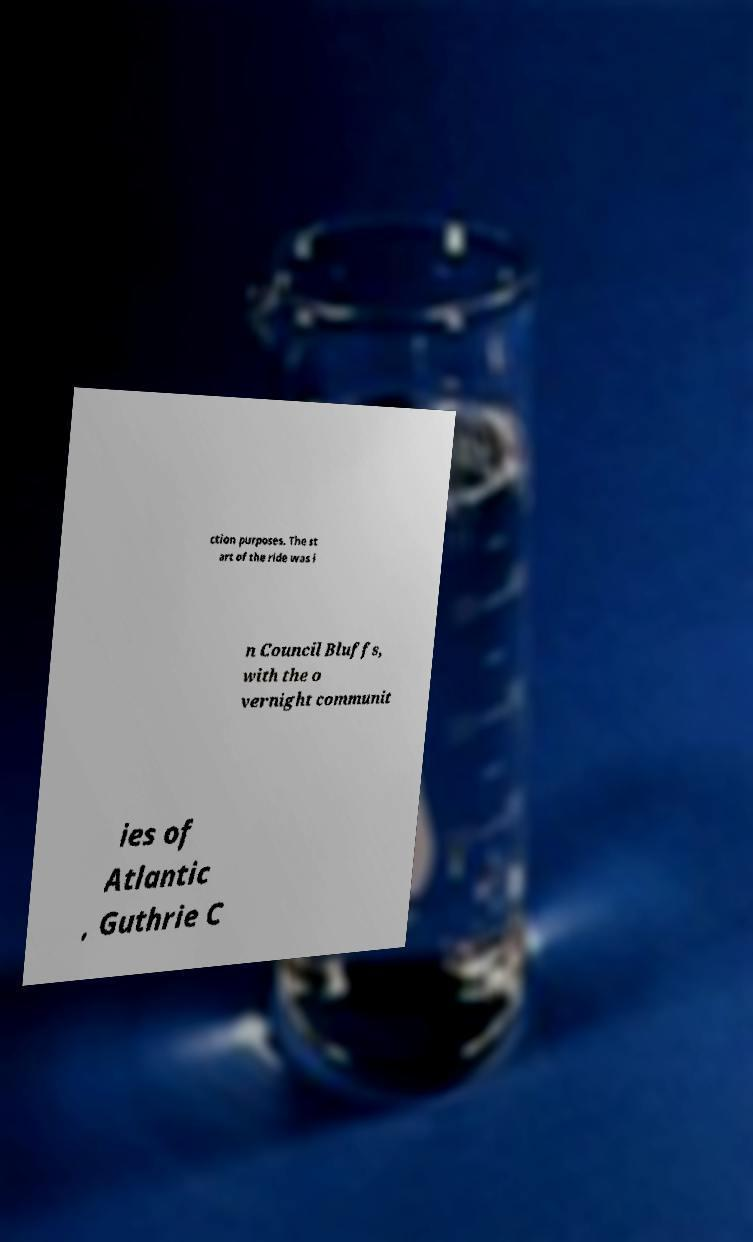I need the written content from this picture converted into text. Can you do that? ction purposes. The st art of the ride was i n Council Bluffs, with the o vernight communit ies of Atlantic , Guthrie C 